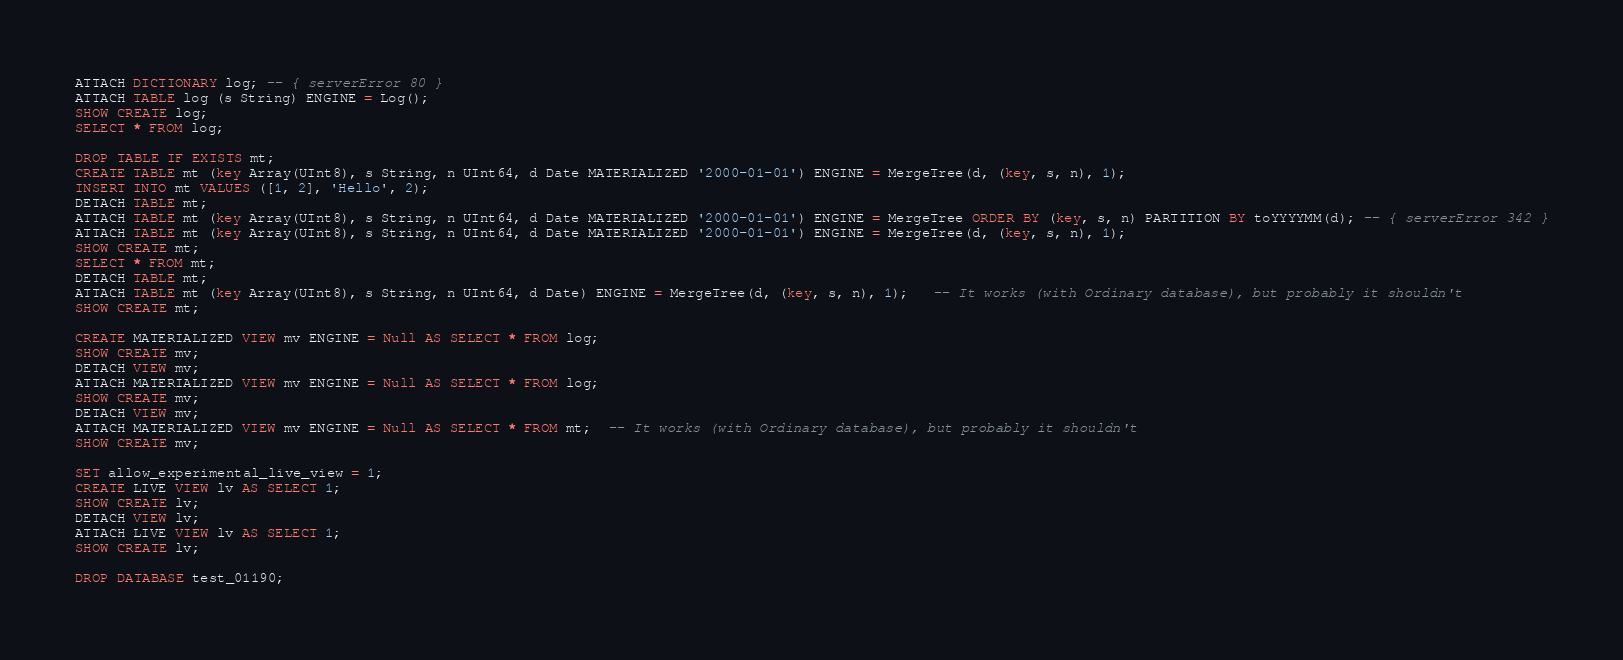Convert code to text. <code><loc_0><loc_0><loc_500><loc_500><_SQL_>ATTACH DICTIONARY log; -- { serverError 80 }
ATTACH TABLE log (s String) ENGINE = Log();
SHOW CREATE log;
SELECT * FROM log;

DROP TABLE IF EXISTS mt;
CREATE TABLE mt (key Array(UInt8), s String, n UInt64, d Date MATERIALIZED '2000-01-01') ENGINE = MergeTree(d, (key, s, n), 1);
INSERT INTO mt VALUES ([1, 2], 'Hello', 2);
DETACH TABLE mt;
ATTACH TABLE mt (key Array(UInt8), s String, n UInt64, d Date MATERIALIZED '2000-01-01') ENGINE = MergeTree ORDER BY (key, s, n) PARTITION BY toYYYYMM(d); -- { serverError 342 }
ATTACH TABLE mt (key Array(UInt8), s String, n UInt64, d Date MATERIALIZED '2000-01-01') ENGINE = MergeTree(d, (key, s, n), 1);
SHOW CREATE mt;
SELECT * FROM mt;
DETACH TABLE mt;
ATTACH TABLE mt (key Array(UInt8), s String, n UInt64, d Date) ENGINE = MergeTree(d, (key, s, n), 1);   -- It works (with Ordinary database), but probably it shouldn't
SHOW CREATE mt;

CREATE MATERIALIZED VIEW mv ENGINE = Null AS SELECT * FROM log;
SHOW CREATE mv;
DETACH VIEW mv;
ATTACH MATERIALIZED VIEW mv ENGINE = Null AS SELECT * FROM log;
SHOW CREATE mv;
DETACH VIEW mv;
ATTACH MATERIALIZED VIEW mv ENGINE = Null AS SELECT * FROM mt;  -- It works (with Ordinary database), but probably it shouldn't
SHOW CREATE mv;

SET allow_experimental_live_view = 1;
CREATE LIVE VIEW lv AS SELECT 1;
SHOW CREATE lv;
DETACH VIEW lv;
ATTACH LIVE VIEW lv AS SELECT 1;
SHOW CREATE lv;

DROP DATABASE test_01190;


</code> 